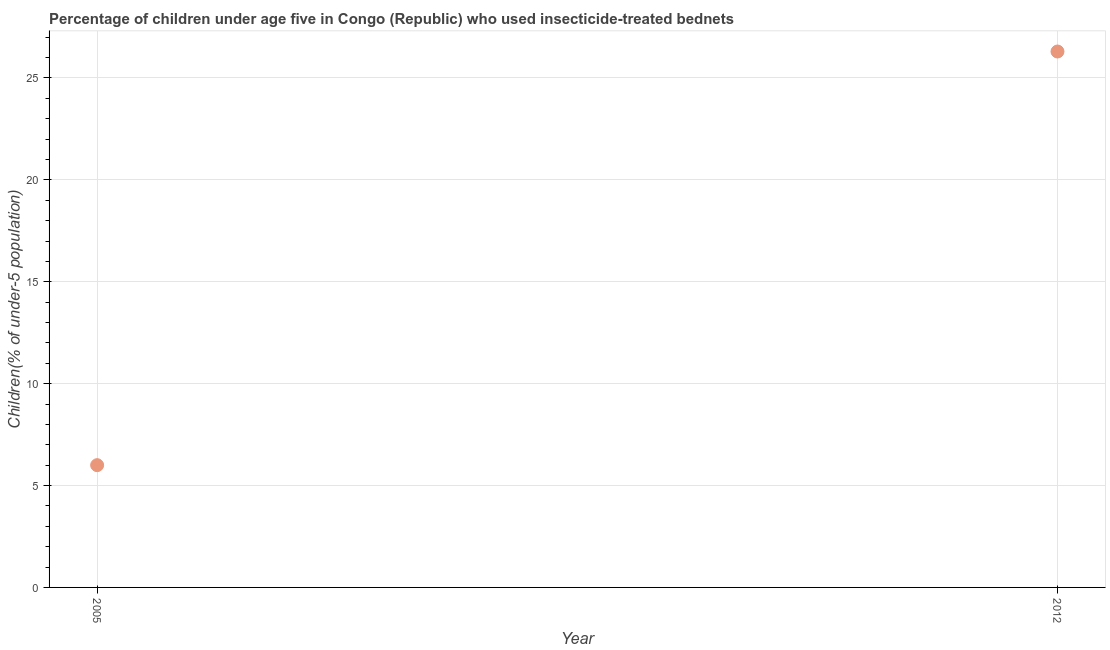What is the percentage of children who use of insecticide-treated bed nets in 2012?
Offer a terse response. 26.3. Across all years, what is the maximum percentage of children who use of insecticide-treated bed nets?
Ensure brevity in your answer.  26.3. Across all years, what is the minimum percentage of children who use of insecticide-treated bed nets?
Your answer should be compact. 6. In which year was the percentage of children who use of insecticide-treated bed nets maximum?
Ensure brevity in your answer.  2012. What is the sum of the percentage of children who use of insecticide-treated bed nets?
Provide a succinct answer. 32.3. What is the difference between the percentage of children who use of insecticide-treated bed nets in 2005 and 2012?
Your answer should be very brief. -20.3. What is the average percentage of children who use of insecticide-treated bed nets per year?
Give a very brief answer. 16.15. What is the median percentage of children who use of insecticide-treated bed nets?
Your response must be concise. 16.15. In how many years, is the percentage of children who use of insecticide-treated bed nets greater than 23 %?
Your response must be concise. 1. What is the ratio of the percentage of children who use of insecticide-treated bed nets in 2005 to that in 2012?
Make the answer very short. 0.23. Is the percentage of children who use of insecticide-treated bed nets in 2005 less than that in 2012?
Your answer should be compact. Yes. In how many years, is the percentage of children who use of insecticide-treated bed nets greater than the average percentage of children who use of insecticide-treated bed nets taken over all years?
Your answer should be very brief. 1. What is the difference between two consecutive major ticks on the Y-axis?
Provide a short and direct response. 5. Are the values on the major ticks of Y-axis written in scientific E-notation?
Your answer should be compact. No. What is the title of the graph?
Keep it short and to the point. Percentage of children under age five in Congo (Republic) who used insecticide-treated bednets. What is the label or title of the X-axis?
Your answer should be compact. Year. What is the label or title of the Y-axis?
Provide a succinct answer. Children(% of under-5 population). What is the Children(% of under-5 population) in 2012?
Keep it short and to the point. 26.3. What is the difference between the Children(% of under-5 population) in 2005 and 2012?
Offer a terse response. -20.3. What is the ratio of the Children(% of under-5 population) in 2005 to that in 2012?
Your response must be concise. 0.23. 